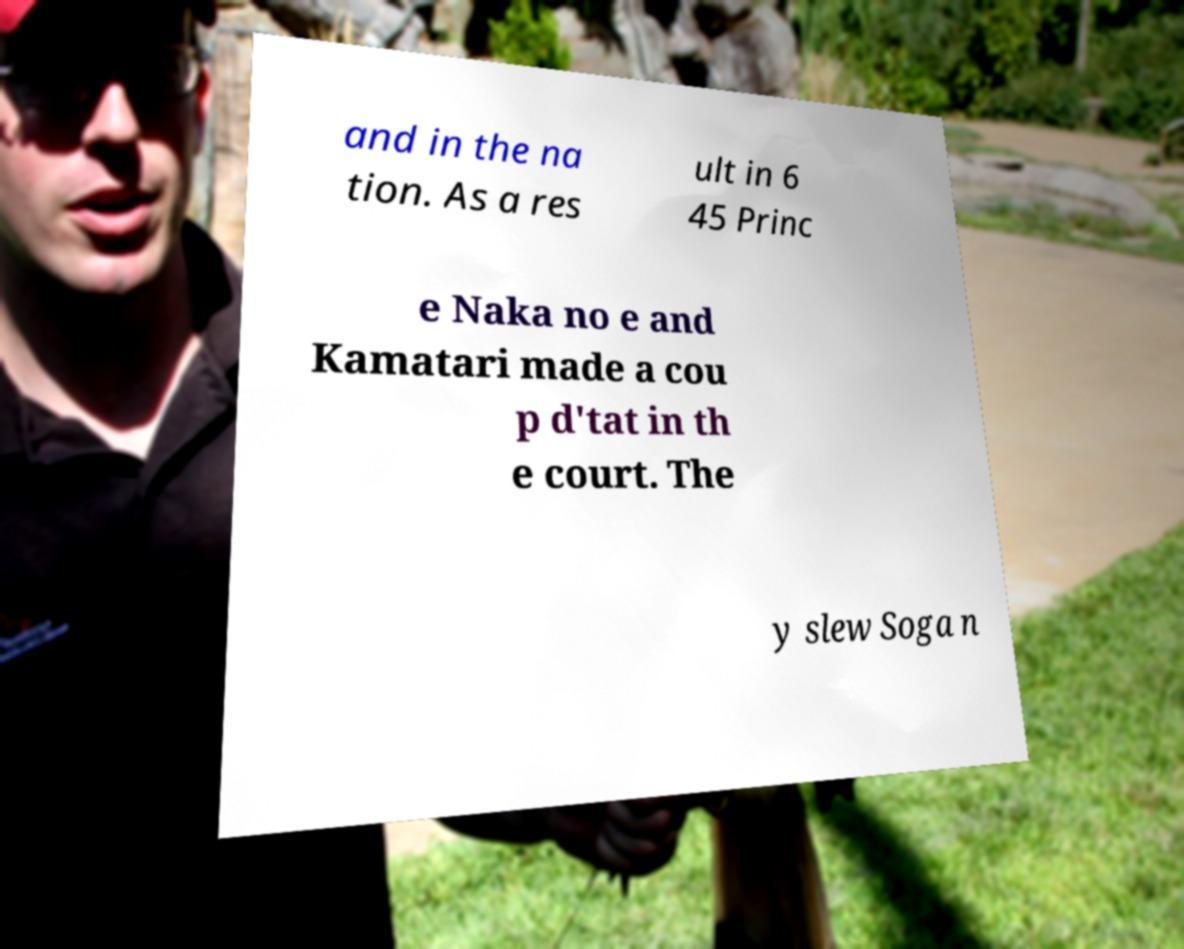Could you assist in decoding the text presented in this image and type it out clearly? and in the na tion. As a res ult in 6 45 Princ e Naka no e and Kamatari made a cou p d'tat in th e court. The y slew Soga n 